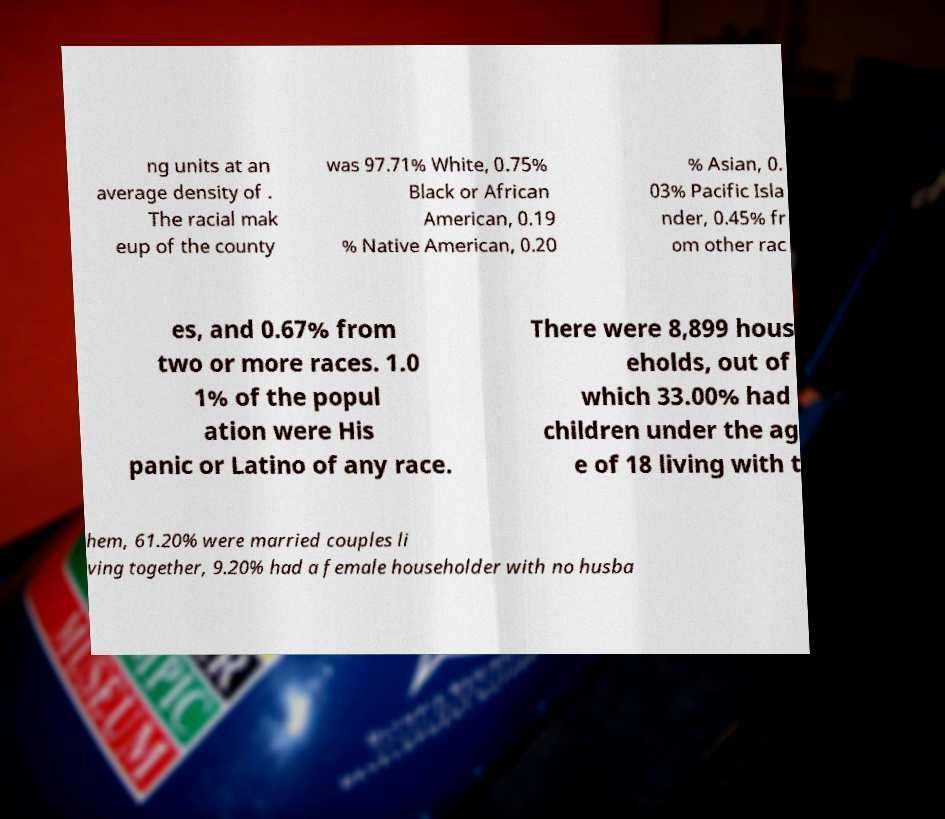Could you assist in decoding the text presented in this image and type it out clearly? ng units at an average density of . The racial mak eup of the county was 97.71% White, 0.75% Black or African American, 0.19 % Native American, 0.20 % Asian, 0. 03% Pacific Isla nder, 0.45% fr om other rac es, and 0.67% from two or more races. 1.0 1% of the popul ation were His panic or Latino of any race. There were 8,899 hous eholds, out of which 33.00% had children under the ag e of 18 living with t hem, 61.20% were married couples li ving together, 9.20% had a female householder with no husba 